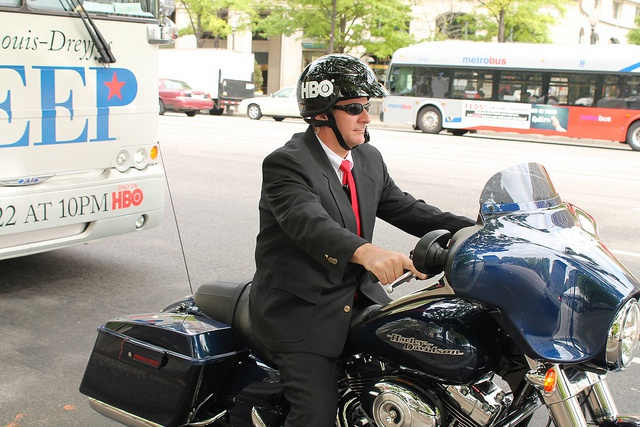Describe the objects in this image and their specific colors. I can see motorcycle in lightgray, black, white, gray, and darkgray tones, bus in lightgray, ivory, lightblue, and darkgray tones, people in lightgray, black, gray, and brown tones, bus in lightgray, white, gray, salmon, and darkgray tones, and suitcase in lightgray, black, gray, maroon, and darkgray tones in this image. 